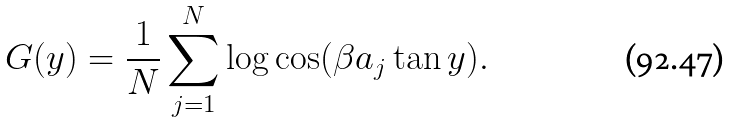<formula> <loc_0><loc_0><loc_500><loc_500>G ( y ) = \frac { 1 } { N } \sum _ { j = 1 } ^ { N } \log \cos ( \beta a _ { j } \tan y ) .</formula> 